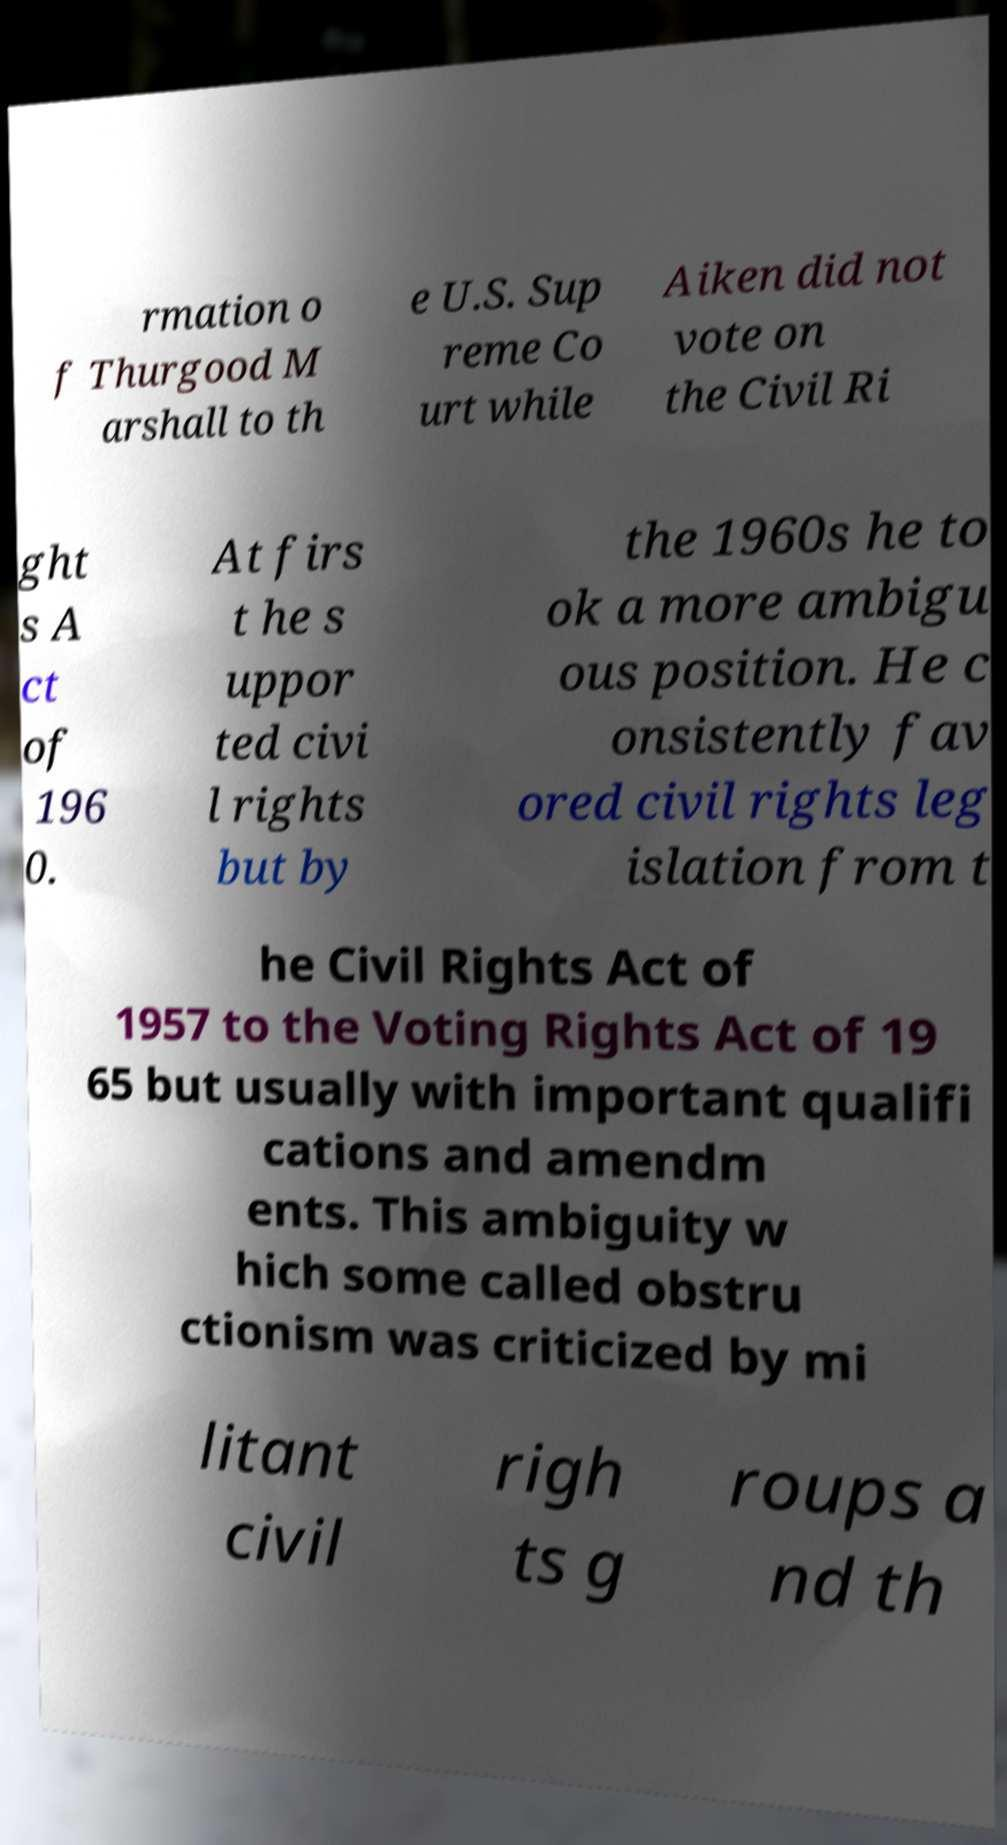Can you read and provide the text displayed in the image?This photo seems to have some interesting text. Can you extract and type it out for me? rmation o f Thurgood M arshall to th e U.S. Sup reme Co urt while Aiken did not vote on the Civil Ri ght s A ct of 196 0. At firs t he s uppor ted civi l rights but by the 1960s he to ok a more ambigu ous position. He c onsistently fav ored civil rights leg islation from t he Civil Rights Act of 1957 to the Voting Rights Act of 19 65 but usually with important qualifi cations and amendm ents. This ambiguity w hich some called obstru ctionism was criticized by mi litant civil righ ts g roups a nd th 